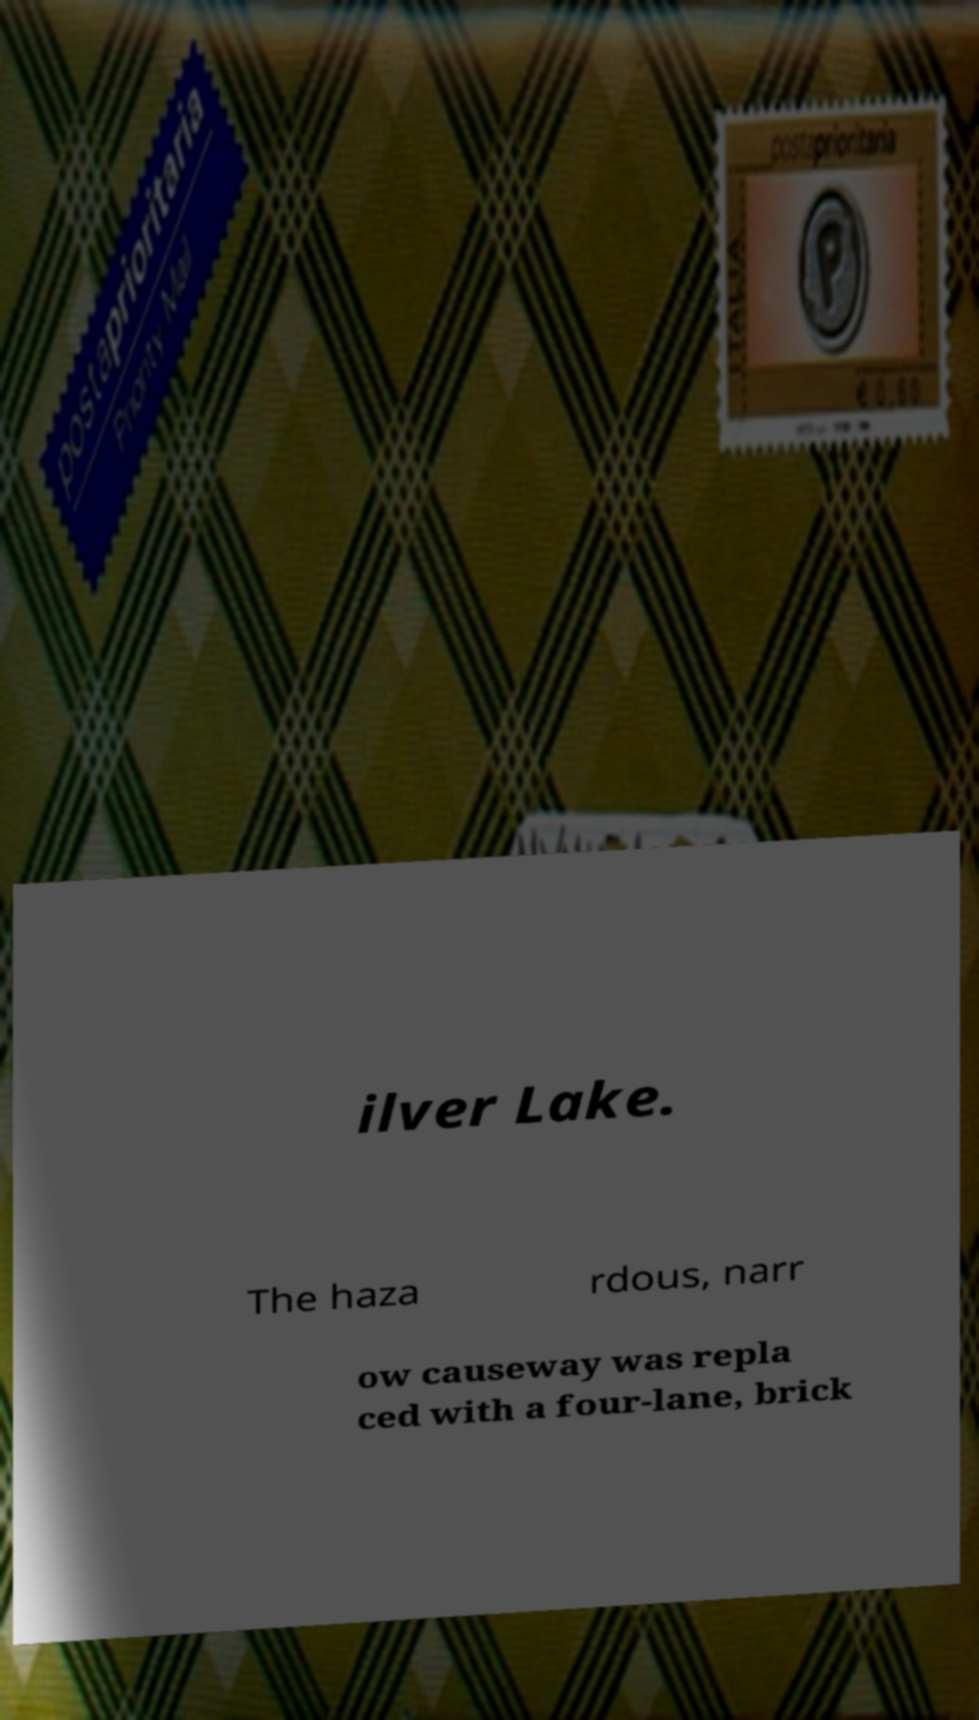Please read and relay the text visible in this image. What does it say? ilver Lake. The haza rdous, narr ow causeway was repla ced with a four-lane, brick 